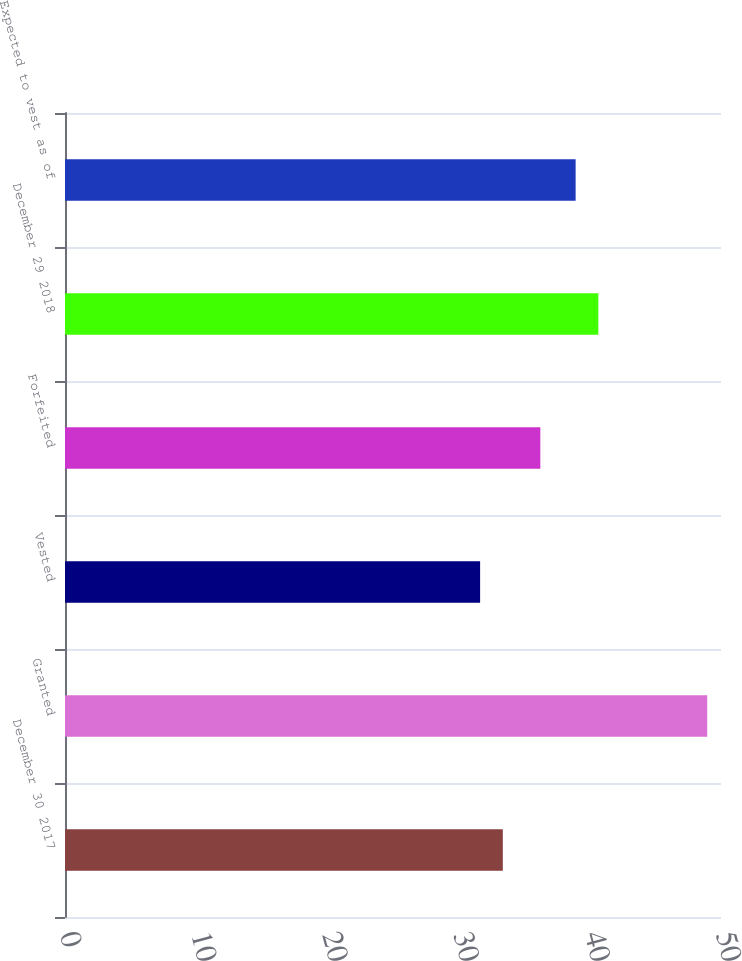Convert chart to OTSL. <chart><loc_0><loc_0><loc_500><loc_500><bar_chart><fcel>December 30 2017<fcel>Granted<fcel>Vested<fcel>Forfeited<fcel>December 29 2018<fcel>Expected to vest as of<nl><fcel>33.37<fcel>48.95<fcel>31.64<fcel>36.23<fcel>40.65<fcel>38.92<nl></chart> 